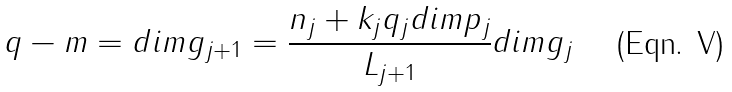<formula> <loc_0><loc_0><loc_500><loc_500>q - m = d i m g _ { j + 1 } = \frac { n _ { j } + k _ { j } q _ { j } d i m p _ { j } } { L _ { j + 1 } } d i m g _ { j }</formula> 